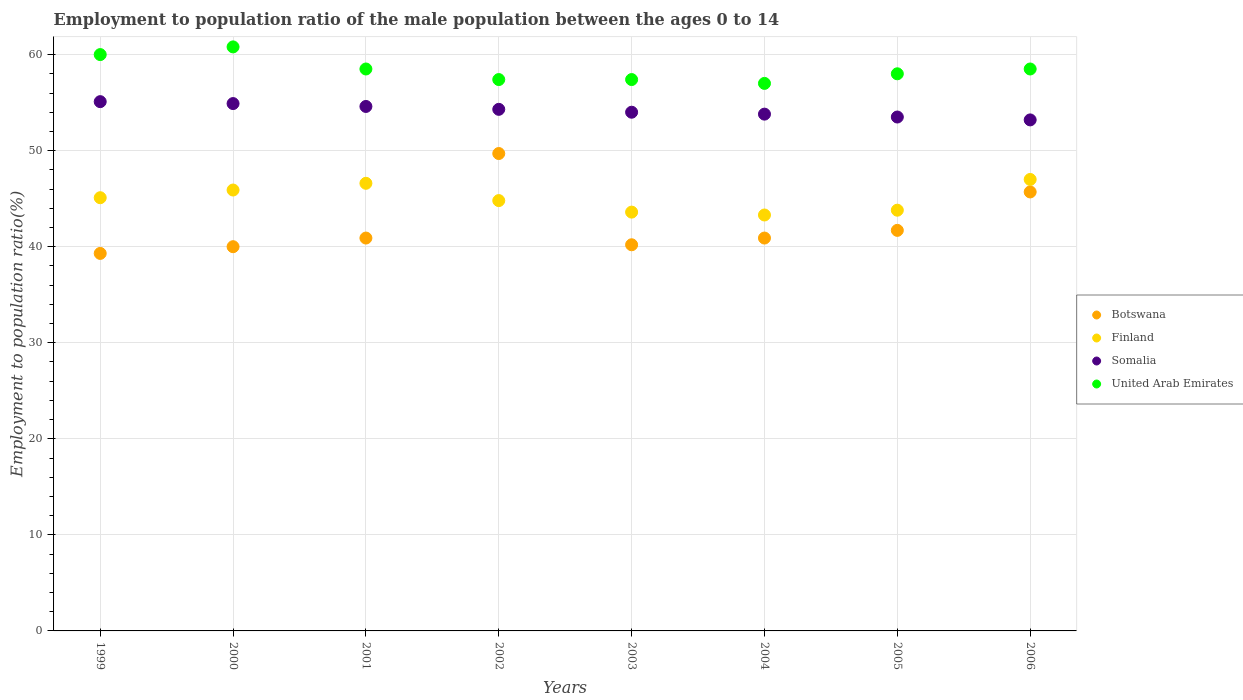How many different coloured dotlines are there?
Ensure brevity in your answer.  4. Across all years, what is the maximum employment to population ratio in United Arab Emirates?
Keep it short and to the point. 60.8. Across all years, what is the minimum employment to population ratio in Somalia?
Make the answer very short. 53.2. In which year was the employment to population ratio in Botswana maximum?
Provide a succinct answer. 2002. In which year was the employment to population ratio in United Arab Emirates minimum?
Provide a succinct answer. 2004. What is the total employment to population ratio in Finland in the graph?
Provide a succinct answer. 360.1. What is the difference between the employment to population ratio in Botswana in 2003 and that in 2004?
Your answer should be compact. -0.7. What is the difference between the employment to population ratio in Finland in 2006 and the employment to population ratio in Somalia in 2004?
Provide a short and direct response. -6.8. What is the average employment to population ratio in United Arab Emirates per year?
Keep it short and to the point. 58.45. In the year 1999, what is the difference between the employment to population ratio in Finland and employment to population ratio in United Arab Emirates?
Offer a terse response. -14.9. In how many years, is the employment to population ratio in Botswana greater than 10 %?
Give a very brief answer. 8. What is the ratio of the employment to population ratio in United Arab Emirates in 2004 to that in 2006?
Your answer should be compact. 0.97. Is the employment to population ratio in Finland in 1999 less than that in 2005?
Offer a terse response. No. What is the difference between the highest and the second highest employment to population ratio in Somalia?
Give a very brief answer. 0.2. What is the difference between the highest and the lowest employment to population ratio in United Arab Emirates?
Ensure brevity in your answer.  3.8. In how many years, is the employment to population ratio in United Arab Emirates greater than the average employment to population ratio in United Arab Emirates taken over all years?
Ensure brevity in your answer.  4. Does the employment to population ratio in Finland monotonically increase over the years?
Provide a succinct answer. No. Is the employment to population ratio in Somalia strictly greater than the employment to population ratio in Botswana over the years?
Offer a terse response. Yes. Is the employment to population ratio in Botswana strictly less than the employment to population ratio in Finland over the years?
Provide a short and direct response. No. How many dotlines are there?
Make the answer very short. 4. How many years are there in the graph?
Offer a very short reply. 8. Are the values on the major ticks of Y-axis written in scientific E-notation?
Provide a succinct answer. No. Does the graph contain any zero values?
Your answer should be very brief. No. Does the graph contain grids?
Your answer should be very brief. Yes. Where does the legend appear in the graph?
Provide a short and direct response. Center right. How many legend labels are there?
Give a very brief answer. 4. What is the title of the graph?
Offer a terse response. Employment to population ratio of the male population between the ages 0 to 14. Does "Indonesia" appear as one of the legend labels in the graph?
Offer a very short reply. No. What is the label or title of the X-axis?
Keep it short and to the point. Years. What is the Employment to population ratio(%) of Botswana in 1999?
Make the answer very short. 39.3. What is the Employment to population ratio(%) of Finland in 1999?
Your answer should be very brief. 45.1. What is the Employment to population ratio(%) in Somalia in 1999?
Your answer should be compact. 55.1. What is the Employment to population ratio(%) of Finland in 2000?
Make the answer very short. 45.9. What is the Employment to population ratio(%) of Somalia in 2000?
Provide a succinct answer. 54.9. What is the Employment to population ratio(%) in United Arab Emirates in 2000?
Your answer should be compact. 60.8. What is the Employment to population ratio(%) in Botswana in 2001?
Your answer should be very brief. 40.9. What is the Employment to population ratio(%) in Finland in 2001?
Provide a short and direct response. 46.6. What is the Employment to population ratio(%) in Somalia in 2001?
Offer a terse response. 54.6. What is the Employment to population ratio(%) in United Arab Emirates in 2001?
Ensure brevity in your answer.  58.5. What is the Employment to population ratio(%) in Botswana in 2002?
Offer a very short reply. 49.7. What is the Employment to population ratio(%) of Finland in 2002?
Your answer should be compact. 44.8. What is the Employment to population ratio(%) of Somalia in 2002?
Your response must be concise. 54.3. What is the Employment to population ratio(%) in United Arab Emirates in 2002?
Ensure brevity in your answer.  57.4. What is the Employment to population ratio(%) in Botswana in 2003?
Your answer should be compact. 40.2. What is the Employment to population ratio(%) in Finland in 2003?
Keep it short and to the point. 43.6. What is the Employment to population ratio(%) of Somalia in 2003?
Provide a short and direct response. 54. What is the Employment to population ratio(%) in United Arab Emirates in 2003?
Ensure brevity in your answer.  57.4. What is the Employment to population ratio(%) in Botswana in 2004?
Keep it short and to the point. 40.9. What is the Employment to population ratio(%) in Finland in 2004?
Offer a terse response. 43.3. What is the Employment to population ratio(%) of Somalia in 2004?
Your answer should be compact. 53.8. What is the Employment to population ratio(%) in Botswana in 2005?
Offer a very short reply. 41.7. What is the Employment to population ratio(%) of Finland in 2005?
Your response must be concise. 43.8. What is the Employment to population ratio(%) in Somalia in 2005?
Offer a very short reply. 53.5. What is the Employment to population ratio(%) of United Arab Emirates in 2005?
Ensure brevity in your answer.  58. What is the Employment to population ratio(%) in Botswana in 2006?
Keep it short and to the point. 45.7. What is the Employment to population ratio(%) in Somalia in 2006?
Offer a terse response. 53.2. What is the Employment to population ratio(%) in United Arab Emirates in 2006?
Give a very brief answer. 58.5. Across all years, what is the maximum Employment to population ratio(%) in Botswana?
Offer a very short reply. 49.7. Across all years, what is the maximum Employment to population ratio(%) in Finland?
Offer a terse response. 47. Across all years, what is the maximum Employment to population ratio(%) in Somalia?
Keep it short and to the point. 55.1. Across all years, what is the maximum Employment to population ratio(%) of United Arab Emirates?
Offer a terse response. 60.8. Across all years, what is the minimum Employment to population ratio(%) in Botswana?
Offer a terse response. 39.3. Across all years, what is the minimum Employment to population ratio(%) in Finland?
Your answer should be compact. 43.3. Across all years, what is the minimum Employment to population ratio(%) of Somalia?
Offer a terse response. 53.2. What is the total Employment to population ratio(%) of Botswana in the graph?
Offer a very short reply. 338.4. What is the total Employment to population ratio(%) in Finland in the graph?
Make the answer very short. 360.1. What is the total Employment to population ratio(%) in Somalia in the graph?
Provide a short and direct response. 433.4. What is the total Employment to population ratio(%) of United Arab Emirates in the graph?
Your answer should be compact. 467.6. What is the difference between the Employment to population ratio(%) in Finland in 1999 and that in 2000?
Your response must be concise. -0.8. What is the difference between the Employment to population ratio(%) in Somalia in 1999 and that in 2000?
Ensure brevity in your answer.  0.2. What is the difference between the Employment to population ratio(%) in United Arab Emirates in 1999 and that in 2001?
Keep it short and to the point. 1.5. What is the difference between the Employment to population ratio(%) in Botswana in 1999 and that in 2002?
Your answer should be very brief. -10.4. What is the difference between the Employment to population ratio(%) in Finland in 1999 and that in 2002?
Provide a short and direct response. 0.3. What is the difference between the Employment to population ratio(%) of Somalia in 1999 and that in 2002?
Your answer should be compact. 0.8. What is the difference between the Employment to population ratio(%) of Finland in 1999 and that in 2003?
Your answer should be compact. 1.5. What is the difference between the Employment to population ratio(%) in United Arab Emirates in 1999 and that in 2003?
Keep it short and to the point. 2.6. What is the difference between the Employment to population ratio(%) in Finland in 1999 and that in 2004?
Your answer should be very brief. 1.8. What is the difference between the Employment to population ratio(%) in Botswana in 1999 and that in 2005?
Your response must be concise. -2.4. What is the difference between the Employment to population ratio(%) in Finland in 1999 and that in 2005?
Keep it short and to the point. 1.3. What is the difference between the Employment to population ratio(%) of Finland in 1999 and that in 2006?
Give a very brief answer. -1.9. What is the difference between the Employment to population ratio(%) in Somalia in 1999 and that in 2006?
Make the answer very short. 1.9. What is the difference between the Employment to population ratio(%) of Botswana in 2000 and that in 2001?
Your answer should be compact. -0.9. What is the difference between the Employment to population ratio(%) of Somalia in 2000 and that in 2001?
Offer a very short reply. 0.3. What is the difference between the Employment to population ratio(%) in United Arab Emirates in 2000 and that in 2001?
Make the answer very short. 2.3. What is the difference between the Employment to population ratio(%) in Botswana in 2000 and that in 2002?
Make the answer very short. -9.7. What is the difference between the Employment to population ratio(%) in Botswana in 2000 and that in 2003?
Provide a succinct answer. -0.2. What is the difference between the Employment to population ratio(%) in United Arab Emirates in 2000 and that in 2003?
Keep it short and to the point. 3.4. What is the difference between the Employment to population ratio(%) of Finland in 2000 and that in 2004?
Offer a terse response. 2.6. What is the difference between the Employment to population ratio(%) of Somalia in 2000 and that in 2004?
Keep it short and to the point. 1.1. What is the difference between the Employment to population ratio(%) of United Arab Emirates in 2000 and that in 2004?
Ensure brevity in your answer.  3.8. What is the difference between the Employment to population ratio(%) of Botswana in 2000 and that in 2005?
Offer a terse response. -1.7. What is the difference between the Employment to population ratio(%) of Finland in 2000 and that in 2005?
Give a very brief answer. 2.1. What is the difference between the Employment to population ratio(%) in United Arab Emirates in 2000 and that in 2005?
Provide a succinct answer. 2.8. What is the difference between the Employment to population ratio(%) in Botswana in 2000 and that in 2006?
Give a very brief answer. -5.7. What is the difference between the Employment to population ratio(%) in United Arab Emirates in 2000 and that in 2006?
Ensure brevity in your answer.  2.3. What is the difference between the Employment to population ratio(%) of Botswana in 2001 and that in 2002?
Ensure brevity in your answer.  -8.8. What is the difference between the Employment to population ratio(%) in Finland in 2001 and that in 2002?
Your response must be concise. 1.8. What is the difference between the Employment to population ratio(%) in Somalia in 2001 and that in 2002?
Your answer should be compact. 0.3. What is the difference between the Employment to population ratio(%) of United Arab Emirates in 2001 and that in 2002?
Offer a terse response. 1.1. What is the difference between the Employment to population ratio(%) of Finland in 2001 and that in 2003?
Offer a very short reply. 3. What is the difference between the Employment to population ratio(%) of United Arab Emirates in 2001 and that in 2003?
Provide a succinct answer. 1.1. What is the difference between the Employment to population ratio(%) of Botswana in 2001 and that in 2004?
Keep it short and to the point. 0. What is the difference between the Employment to population ratio(%) of Finland in 2001 and that in 2004?
Offer a very short reply. 3.3. What is the difference between the Employment to population ratio(%) of Finland in 2001 and that in 2005?
Offer a terse response. 2.8. What is the difference between the Employment to population ratio(%) in United Arab Emirates in 2001 and that in 2005?
Provide a short and direct response. 0.5. What is the difference between the Employment to population ratio(%) of Finland in 2001 and that in 2006?
Your answer should be compact. -0.4. What is the difference between the Employment to population ratio(%) of Botswana in 2002 and that in 2003?
Your answer should be very brief. 9.5. What is the difference between the Employment to population ratio(%) of Finland in 2002 and that in 2003?
Make the answer very short. 1.2. What is the difference between the Employment to population ratio(%) of Finland in 2002 and that in 2004?
Your answer should be compact. 1.5. What is the difference between the Employment to population ratio(%) of Somalia in 2002 and that in 2004?
Offer a terse response. 0.5. What is the difference between the Employment to population ratio(%) of Botswana in 2002 and that in 2005?
Ensure brevity in your answer.  8. What is the difference between the Employment to population ratio(%) of Finland in 2002 and that in 2005?
Your response must be concise. 1. What is the difference between the Employment to population ratio(%) of Somalia in 2002 and that in 2005?
Give a very brief answer. 0.8. What is the difference between the Employment to population ratio(%) of Botswana in 2002 and that in 2006?
Keep it short and to the point. 4. What is the difference between the Employment to population ratio(%) of Finland in 2003 and that in 2004?
Provide a succinct answer. 0.3. What is the difference between the Employment to population ratio(%) of Botswana in 2003 and that in 2005?
Offer a terse response. -1.5. What is the difference between the Employment to population ratio(%) in Finland in 2003 and that in 2005?
Make the answer very short. -0.2. What is the difference between the Employment to population ratio(%) of Somalia in 2003 and that in 2006?
Keep it short and to the point. 0.8. What is the difference between the Employment to population ratio(%) of United Arab Emirates in 2003 and that in 2006?
Keep it short and to the point. -1.1. What is the difference between the Employment to population ratio(%) of Botswana in 2004 and that in 2005?
Ensure brevity in your answer.  -0.8. What is the difference between the Employment to population ratio(%) of United Arab Emirates in 2004 and that in 2005?
Provide a short and direct response. -1. What is the difference between the Employment to population ratio(%) in Botswana in 2004 and that in 2006?
Keep it short and to the point. -4.8. What is the difference between the Employment to population ratio(%) in Botswana in 2005 and that in 2006?
Give a very brief answer. -4. What is the difference between the Employment to population ratio(%) of Finland in 2005 and that in 2006?
Make the answer very short. -3.2. What is the difference between the Employment to population ratio(%) of Botswana in 1999 and the Employment to population ratio(%) of Finland in 2000?
Provide a short and direct response. -6.6. What is the difference between the Employment to population ratio(%) in Botswana in 1999 and the Employment to population ratio(%) in Somalia in 2000?
Your answer should be very brief. -15.6. What is the difference between the Employment to population ratio(%) of Botswana in 1999 and the Employment to population ratio(%) of United Arab Emirates in 2000?
Make the answer very short. -21.5. What is the difference between the Employment to population ratio(%) of Finland in 1999 and the Employment to population ratio(%) of Somalia in 2000?
Make the answer very short. -9.8. What is the difference between the Employment to population ratio(%) of Finland in 1999 and the Employment to population ratio(%) of United Arab Emirates in 2000?
Provide a short and direct response. -15.7. What is the difference between the Employment to population ratio(%) of Botswana in 1999 and the Employment to population ratio(%) of Finland in 2001?
Ensure brevity in your answer.  -7.3. What is the difference between the Employment to population ratio(%) in Botswana in 1999 and the Employment to population ratio(%) in Somalia in 2001?
Provide a succinct answer. -15.3. What is the difference between the Employment to population ratio(%) in Botswana in 1999 and the Employment to population ratio(%) in United Arab Emirates in 2001?
Your answer should be very brief. -19.2. What is the difference between the Employment to population ratio(%) of Botswana in 1999 and the Employment to population ratio(%) of Finland in 2002?
Your response must be concise. -5.5. What is the difference between the Employment to population ratio(%) in Botswana in 1999 and the Employment to population ratio(%) in Somalia in 2002?
Keep it short and to the point. -15. What is the difference between the Employment to population ratio(%) in Botswana in 1999 and the Employment to population ratio(%) in United Arab Emirates in 2002?
Offer a very short reply. -18.1. What is the difference between the Employment to population ratio(%) of Somalia in 1999 and the Employment to population ratio(%) of United Arab Emirates in 2002?
Provide a short and direct response. -2.3. What is the difference between the Employment to population ratio(%) of Botswana in 1999 and the Employment to population ratio(%) of Somalia in 2003?
Your answer should be compact. -14.7. What is the difference between the Employment to population ratio(%) of Botswana in 1999 and the Employment to population ratio(%) of United Arab Emirates in 2003?
Your answer should be very brief. -18.1. What is the difference between the Employment to population ratio(%) of Somalia in 1999 and the Employment to population ratio(%) of United Arab Emirates in 2003?
Keep it short and to the point. -2.3. What is the difference between the Employment to population ratio(%) in Botswana in 1999 and the Employment to population ratio(%) in Finland in 2004?
Provide a succinct answer. -4. What is the difference between the Employment to population ratio(%) in Botswana in 1999 and the Employment to population ratio(%) in United Arab Emirates in 2004?
Provide a short and direct response. -17.7. What is the difference between the Employment to population ratio(%) of Somalia in 1999 and the Employment to population ratio(%) of United Arab Emirates in 2004?
Ensure brevity in your answer.  -1.9. What is the difference between the Employment to population ratio(%) of Botswana in 1999 and the Employment to population ratio(%) of Somalia in 2005?
Give a very brief answer. -14.2. What is the difference between the Employment to population ratio(%) of Botswana in 1999 and the Employment to population ratio(%) of United Arab Emirates in 2005?
Keep it short and to the point. -18.7. What is the difference between the Employment to population ratio(%) of Finland in 1999 and the Employment to population ratio(%) of Somalia in 2005?
Your answer should be compact. -8.4. What is the difference between the Employment to population ratio(%) in Finland in 1999 and the Employment to population ratio(%) in United Arab Emirates in 2005?
Your response must be concise. -12.9. What is the difference between the Employment to population ratio(%) of Somalia in 1999 and the Employment to population ratio(%) of United Arab Emirates in 2005?
Give a very brief answer. -2.9. What is the difference between the Employment to population ratio(%) in Botswana in 1999 and the Employment to population ratio(%) in Finland in 2006?
Provide a short and direct response. -7.7. What is the difference between the Employment to population ratio(%) in Botswana in 1999 and the Employment to population ratio(%) in Somalia in 2006?
Provide a short and direct response. -13.9. What is the difference between the Employment to population ratio(%) in Botswana in 1999 and the Employment to population ratio(%) in United Arab Emirates in 2006?
Your answer should be compact. -19.2. What is the difference between the Employment to population ratio(%) of Finland in 1999 and the Employment to population ratio(%) of Somalia in 2006?
Ensure brevity in your answer.  -8.1. What is the difference between the Employment to population ratio(%) in Botswana in 2000 and the Employment to population ratio(%) in Somalia in 2001?
Your answer should be compact. -14.6. What is the difference between the Employment to population ratio(%) of Botswana in 2000 and the Employment to population ratio(%) of United Arab Emirates in 2001?
Your answer should be compact. -18.5. What is the difference between the Employment to population ratio(%) in Finland in 2000 and the Employment to population ratio(%) in Somalia in 2001?
Provide a short and direct response. -8.7. What is the difference between the Employment to population ratio(%) of Botswana in 2000 and the Employment to population ratio(%) of Finland in 2002?
Offer a very short reply. -4.8. What is the difference between the Employment to population ratio(%) of Botswana in 2000 and the Employment to population ratio(%) of Somalia in 2002?
Offer a very short reply. -14.3. What is the difference between the Employment to population ratio(%) in Botswana in 2000 and the Employment to population ratio(%) in United Arab Emirates in 2002?
Give a very brief answer. -17.4. What is the difference between the Employment to population ratio(%) of Finland in 2000 and the Employment to population ratio(%) of Somalia in 2002?
Give a very brief answer. -8.4. What is the difference between the Employment to population ratio(%) in Finland in 2000 and the Employment to population ratio(%) in United Arab Emirates in 2002?
Provide a short and direct response. -11.5. What is the difference between the Employment to population ratio(%) of Botswana in 2000 and the Employment to population ratio(%) of Somalia in 2003?
Provide a succinct answer. -14. What is the difference between the Employment to population ratio(%) of Botswana in 2000 and the Employment to population ratio(%) of United Arab Emirates in 2003?
Provide a succinct answer. -17.4. What is the difference between the Employment to population ratio(%) in Botswana in 2000 and the Employment to population ratio(%) in Finland in 2004?
Offer a very short reply. -3.3. What is the difference between the Employment to population ratio(%) in Botswana in 2000 and the Employment to population ratio(%) in Somalia in 2004?
Keep it short and to the point. -13.8. What is the difference between the Employment to population ratio(%) in Botswana in 2000 and the Employment to population ratio(%) in United Arab Emirates in 2005?
Your response must be concise. -18. What is the difference between the Employment to population ratio(%) of Finland in 2000 and the Employment to population ratio(%) of United Arab Emirates in 2005?
Your answer should be compact. -12.1. What is the difference between the Employment to population ratio(%) in Botswana in 2000 and the Employment to population ratio(%) in Somalia in 2006?
Your response must be concise. -13.2. What is the difference between the Employment to population ratio(%) in Botswana in 2000 and the Employment to population ratio(%) in United Arab Emirates in 2006?
Keep it short and to the point. -18.5. What is the difference between the Employment to population ratio(%) of Finland in 2000 and the Employment to population ratio(%) of Somalia in 2006?
Keep it short and to the point. -7.3. What is the difference between the Employment to population ratio(%) in Botswana in 2001 and the Employment to population ratio(%) in United Arab Emirates in 2002?
Your answer should be very brief. -16.5. What is the difference between the Employment to population ratio(%) in Finland in 2001 and the Employment to population ratio(%) in Somalia in 2002?
Make the answer very short. -7.7. What is the difference between the Employment to population ratio(%) of Somalia in 2001 and the Employment to population ratio(%) of United Arab Emirates in 2002?
Ensure brevity in your answer.  -2.8. What is the difference between the Employment to population ratio(%) in Botswana in 2001 and the Employment to population ratio(%) in Finland in 2003?
Offer a very short reply. -2.7. What is the difference between the Employment to population ratio(%) of Botswana in 2001 and the Employment to population ratio(%) of United Arab Emirates in 2003?
Your answer should be very brief. -16.5. What is the difference between the Employment to population ratio(%) in Finland in 2001 and the Employment to population ratio(%) in Somalia in 2003?
Ensure brevity in your answer.  -7.4. What is the difference between the Employment to population ratio(%) in Finland in 2001 and the Employment to population ratio(%) in United Arab Emirates in 2003?
Give a very brief answer. -10.8. What is the difference between the Employment to population ratio(%) of Somalia in 2001 and the Employment to population ratio(%) of United Arab Emirates in 2003?
Offer a very short reply. -2.8. What is the difference between the Employment to population ratio(%) in Botswana in 2001 and the Employment to population ratio(%) in Somalia in 2004?
Your answer should be very brief. -12.9. What is the difference between the Employment to population ratio(%) in Botswana in 2001 and the Employment to population ratio(%) in United Arab Emirates in 2004?
Provide a succinct answer. -16.1. What is the difference between the Employment to population ratio(%) in Finland in 2001 and the Employment to population ratio(%) in Somalia in 2004?
Provide a succinct answer. -7.2. What is the difference between the Employment to population ratio(%) in Somalia in 2001 and the Employment to population ratio(%) in United Arab Emirates in 2004?
Make the answer very short. -2.4. What is the difference between the Employment to population ratio(%) of Botswana in 2001 and the Employment to population ratio(%) of Finland in 2005?
Offer a terse response. -2.9. What is the difference between the Employment to population ratio(%) in Botswana in 2001 and the Employment to population ratio(%) in United Arab Emirates in 2005?
Make the answer very short. -17.1. What is the difference between the Employment to population ratio(%) in Finland in 2001 and the Employment to population ratio(%) in Somalia in 2005?
Your answer should be very brief. -6.9. What is the difference between the Employment to population ratio(%) of Finland in 2001 and the Employment to population ratio(%) of United Arab Emirates in 2005?
Your response must be concise. -11.4. What is the difference between the Employment to population ratio(%) of Somalia in 2001 and the Employment to population ratio(%) of United Arab Emirates in 2005?
Your response must be concise. -3.4. What is the difference between the Employment to population ratio(%) of Botswana in 2001 and the Employment to population ratio(%) of United Arab Emirates in 2006?
Keep it short and to the point. -17.6. What is the difference between the Employment to population ratio(%) in Finland in 2001 and the Employment to population ratio(%) in Somalia in 2006?
Provide a succinct answer. -6.6. What is the difference between the Employment to population ratio(%) in Finland in 2001 and the Employment to population ratio(%) in United Arab Emirates in 2006?
Provide a succinct answer. -11.9. What is the difference between the Employment to population ratio(%) in Somalia in 2001 and the Employment to population ratio(%) in United Arab Emirates in 2006?
Your response must be concise. -3.9. What is the difference between the Employment to population ratio(%) in Finland in 2002 and the Employment to population ratio(%) in Somalia in 2003?
Your answer should be compact. -9.2. What is the difference between the Employment to population ratio(%) in Finland in 2002 and the Employment to population ratio(%) in United Arab Emirates in 2003?
Your answer should be very brief. -12.6. What is the difference between the Employment to population ratio(%) of Botswana in 2002 and the Employment to population ratio(%) of Finland in 2004?
Provide a short and direct response. 6.4. What is the difference between the Employment to population ratio(%) of Botswana in 2002 and the Employment to population ratio(%) of United Arab Emirates in 2004?
Keep it short and to the point. -7.3. What is the difference between the Employment to population ratio(%) of Somalia in 2002 and the Employment to population ratio(%) of United Arab Emirates in 2004?
Offer a very short reply. -2.7. What is the difference between the Employment to population ratio(%) in Botswana in 2002 and the Employment to population ratio(%) in Somalia in 2005?
Give a very brief answer. -3.8. What is the difference between the Employment to population ratio(%) of Botswana in 2002 and the Employment to population ratio(%) of United Arab Emirates in 2005?
Ensure brevity in your answer.  -8.3. What is the difference between the Employment to population ratio(%) in Finland in 2002 and the Employment to population ratio(%) in United Arab Emirates in 2005?
Offer a terse response. -13.2. What is the difference between the Employment to population ratio(%) in Somalia in 2002 and the Employment to population ratio(%) in United Arab Emirates in 2005?
Offer a very short reply. -3.7. What is the difference between the Employment to population ratio(%) in Botswana in 2002 and the Employment to population ratio(%) in Finland in 2006?
Make the answer very short. 2.7. What is the difference between the Employment to population ratio(%) of Finland in 2002 and the Employment to population ratio(%) of Somalia in 2006?
Give a very brief answer. -8.4. What is the difference between the Employment to population ratio(%) of Finland in 2002 and the Employment to population ratio(%) of United Arab Emirates in 2006?
Provide a succinct answer. -13.7. What is the difference between the Employment to population ratio(%) of Botswana in 2003 and the Employment to population ratio(%) of Somalia in 2004?
Your answer should be compact. -13.6. What is the difference between the Employment to population ratio(%) in Botswana in 2003 and the Employment to population ratio(%) in United Arab Emirates in 2004?
Offer a very short reply. -16.8. What is the difference between the Employment to population ratio(%) of Botswana in 2003 and the Employment to population ratio(%) of Somalia in 2005?
Keep it short and to the point. -13.3. What is the difference between the Employment to population ratio(%) of Botswana in 2003 and the Employment to population ratio(%) of United Arab Emirates in 2005?
Your answer should be very brief. -17.8. What is the difference between the Employment to population ratio(%) in Finland in 2003 and the Employment to population ratio(%) in United Arab Emirates in 2005?
Your answer should be very brief. -14.4. What is the difference between the Employment to population ratio(%) in Botswana in 2003 and the Employment to population ratio(%) in Finland in 2006?
Provide a short and direct response. -6.8. What is the difference between the Employment to population ratio(%) in Botswana in 2003 and the Employment to population ratio(%) in Somalia in 2006?
Provide a short and direct response. -13. What is the difference between the Employment to population ratio(%) of Botswana in 2003 and the Employment to population ratio(%) of United Arab Emirates in 2006?
Give a very brief answer. -18.3. What is the difference between the Employment to population ratio(%) of Finland in 2003 and the Employment to population ratio(%) of Somalia in 2006?
Ensure brevity in your answer.  -9.6. What is the difference between the Employment to population ratio(%) of Finland in 2003 and the Employment to population ratio(%) of United Arab Emirates in 2006?
Provide a succinct answer. -14.9. What is the difference between the Employment to population ratio(%) of Botswana in 2004 and the Employment to population ratio(%) of Finland in 2005?
Your answer should be very brief. -2.9. What is the difference between the Employment to population ratio(%) of Botswana in 2004 and the Employment to population ratio(%) of United Arab Emirates in 2005?
Your response must be concise. -17.1. What is the difference between the Employment to population ratio(%) in Finland in 2004 and the Employment to population ratio(%) in United Arab Emirates in 2005?
Provide a succinct answer. -14.7. What is the difference between the Employment to population ratio(%) in Botswana in 2004 and the Employment to population ratio(%) in United Arab Emirates in 2006?
Ensure brevity in your answer.  -17.6. What is the difference between the Employment to population ratio(%) in Finland in 2004 and the Employment to population ratio(%) in United Arab Emirates in 2006?
Your answer should be compact. -15.2. What is the difference between the Employment to population ratio(%) in Somalia in 2004 and the Employment to population ratio(%) in United Arab Emirates in 2006?
Your answer should be very brief. -4.7. What is the difference between the Employment to population ratio(%) in Botswana in 2005 and the Employment to population ratio(%) in Finland in 2006?
Your answer should be very brief. -5.3. What is the difference between the Employment to population ratio(%) in Botswana in 2005 and the Employment to population ratio(%) in United Arab Emirates in 2006?
Offer a terse response. -16.8. What is the difference between the Employment to population ratio(%) in Finland in 2005 and the Employment to population ratio(%) in Somalia in 2006?
Your answer should be compact. -9.4. What is the difference between the Employment to population ratio(%) in Finland in 2005 and the Employment to population ratio(%) in United Arab Emirates in 2006?
Keep it short and to the point. -14.7. What is the average Employment to population ratio(%) of Botswana per year?
Your answer should be very brief. 42.3. What is the average Employment to population ratio(%) in Finland per year?
Provide a succinct answer. 45.01. What is the average Employment to population ratio(%) in Somalia per year?
Offer a terse response. 54.17. What is the average Employment to population ratio(%) of United Arab Emirates per year?
Your answer should be compact. 58.45. In the year 1999, what is the difference between the Employment to population ratio(%) of Botswana and Employment to population ratio(%) of Finland?
Ensure brevity in your answer.  -5.8. In the year 1999, what is the difference between the Employment to population ratio(%) of Botswana and Employment to population ratio(%) of Somalia?
Provide a succinct answer. -15.8. In the year 1999, what is the difference between the Employment to population ratio(%) of Botswana and Employment to population ratio(%) of United Arab Emirates?
Give a very brief answer. -20.7. In the year 1999, what is the difference between the Employment to population ratio(%) in Finland and Employment to population ratio(%) in United Arab Emirates?
Give a very brief answer. -14.9. In the year 1999, what is the difference between the Employment to population ratio(%) in Somalia and Employment to population ratio(%) in United Arab Emirates?
Keep it short and to the point. -4.9. In the year 2000, what is the difference between the Employment to population ratio(%) in Botswana and Employment to population ratio(%) in Somalia?
Keep it short and to the point. -14.9. In the year 2000, what is the difference between the Employment to population ratio(%) of Botswana and Employment to population ratio(%) of United Arab Emirates?
Ensure brevity in your answer.  -20.8. In the year 2000, what is the difference between the Employment to population ratio(%) in Finland and Employment to population ratio(%) in United Arab Emirates?
Your answer should be very brief. -14.9. In the year 2000, what is the difference between the Employment to population ratio(%) in Somalia and Employment to population ratio(%) in United Arab Emirates?
Offer a terse response. -5.9. In the year 2001, what is the difference between the Employment to population ratio(%) of Botswana and Employment to population ratio(%) of Somalia?
Your answer should be very brief. -13.7. In the year 2001, what is the difference between the Employment to population ratio(%) of Botswana and Employment to population ratio(%) of United Arab Emirates?
Your response must be concise. -17.6. In the year 2001, what is the difference between the Employment to population ratio(%) in Finland and Employment to population ratio(%) in United Arab Emirates?
Offer a terse response. -11.9. In the year 2002, what is the difference between the Employment to population ratio(%) in Botswana and Employment to population ratio(%) in Finland?
Make the answer very short. 4.9. In the year 2002, what is the difference between the Employment to population ratio(%) in Botswana and Employment to population ratio(%) in Somalia?
Give a very brief answer. -4.6. In the year 2002, what is the difference between the Employment to population ratio(%) in Finland and Employment to population ratio(%) in Somalia?
Offer a terse response. -9.5. In the year 2003, what is the difference between the Employment to population ratio(%) of Botswana and Employment to population ratio(%) of United Arab Emirates?
Your answer should be compact. -17.2. In the year 2003, what is the difference between the Employment to population ratio(%) in Somalia and Employment to population ratio(%) in United Arab Emirates?
Your response must be concise. -3.4. In the year 2004, what is the difference between the Employment to population ratio(%) of Botswana and Employment to population ratio(%) of Finland?
Your response must be concise. -2.4. In the year 2004, what is the difference between the Employment to population ratio(%) in Botswana and Employment to population ratio(%) in United Arab Emirates?
Provide a succinct answer. -16.1. In the year 2004, what is the difference between the Employment to population ratio(%) of Finland and Employment to population ratio(%) of Somalia?
Your answer should be very brief. -10.5. In the year 2004, what is the difference between the Employment to population ratio(%) in Finland and Employment to population ratio(%) in United Arab Emirates?
Your answer should be very brief. -13.7. In the year 2005, what is the difference between the Employment to population ratio(%) of Botswana and Employment to population ratio(%) of United Arab Emirates?
Ensure brevity in your answer.  -16.3. In the year 2005, what is the difference between the Employment to population ratio(%) in Finland and Employment to population ratio(%) in Somalia?
Offer a terse response. -9.7. In the year 2005, what is the difference between the Employment to population ratio(%) of Somalia and Employment to population ratio(%) of United Arab Emirates?
Provide a short and direct response. -4.5. In the year 2006, what is the difference between the Employment to population ratio(%) in Botswana and Employment to population ratio(%) in Somalia?
Provide a succinct answer. -7.5. In the year 2006, what is the difference between the Employment to population ratio(%) of Finland and Employment to population ratio(%) of Somalia?
Offer a very short reply. -6.2. What is the ratio of the Employment to population ratio(%) of Botswana in 1999 to that in 2000?
Give a very brief answer. 0.98. What is the ratio of the Employment to population ratio(%) of Finland in 1999 to that in 2000?
Offer a very short reply. 0.98. What is the ratio of the Employment to population ratio(%) in Somalia in 1999 to that in 2000?
Your answer should be very brief. 1. What is the ratio of the Employment to population ratio(%) in United Arab Emirates in 1999 to that in 2000?
Offer a very short reply. 0.99. What is the ratio of the Employment to population ratio(%) of Botswana in 1999 to that in 2001?
Offer a very short reply. 0.96. What is the ratio of the Employment to population ratio(%) of Finland in 1999 to that in 2001?
Give a very brief answer. 0.97. What is the ratio of the Employment to population ratio(%) of Somalia in 1999 to that in 2001?
Offer a terse response. 1.01. What is the ratio of the Employment to population ratio(%) of United Arab Emirates in 1999 to that in 2001?
Offer a terse response. 1.03. What is the ratio of the Employment to population ratio(%) in Botswana in 1999 to that in 2002?
Provide a short and direct response. 0.79. What is the ratio of the Employment to population ratio(%) in Somalia in 1999 to that in 2002?
Your response must be concise. 1.01. What is the ratio of the Employment to population ratio(%) of United Arab Emirates in 1999 to that in 2002?
Your answer should be compact. 1.05. What is the ratio of the Employment to population ratio(%) of Botswana in 1999 to that in 2003?
Ensure brevity in your answer.  0.98. What is the ratio of the Employment to population ratio(%) of Finland in 1999 to that in 2003?
Your answer should be very brief. 1.03. What is the ratio of the Employment to population ratio(%) in Somalia in 1999 to that in 2003?
Your answer should be very brief. 1.02. What is the ratio of the Employment to population ratio(%) in United Arab Emirates in 1999 to that in 2003?
Provide a succinct answer. 1.05. What is the ratio of the Employment to population ratio(%) in Botswana in 1999 to that in 2004?
Your response must be concise. 0.96. What is the ratio of the Employment to population ratio(%) of Finland in 1999 to that in 2004?
Your answer should be very brief. 1.04. What is the ratio of the Employment to population ratio(%) in Somalia in 1999 to that in 2004?
Offer a terse response. 1.02. What is the ratio of the Employment to population ratio(%) of United Arab Emirates in 1999 to that in 2004?
Offer a terse response. 1.05. What is the ratio of the Employment to population ratio(%) of Botswana in 1999 to that in 2005?
Offer a very short reply. 0.94. What is the ratio of the Employment to population ratio(%) in Finland in 1999 to that in 2005?
Provide a short and direct response. 1.03. What is the ratio of the Employment to population ratio(%) in Somalia in 1999 to that in 2005?
Your response must be concise. 1.03. What is the ratio of the Employment to population ratio(%) of United Arab Emirates in 1999 to that in 2005?
Your answer should be very brief. 1.03. What is the ratio of the Employment to population ratio(%) in Botswana in 1999 to that in 2006?
Your response must be concise. 0.86. What is the ratio of the Employment to population ratio(%) of Finland in 1999 to that in 2006?
Make the answer very short. 0.96. What is the ratio of the Employment to population ratio(%) in Somalia in 1999 to that in 2006?
Offer a very short reply. 1.04. What is the ratio of the Employment to population ratio(%) of United Arab Emirates in 1999 to that in 2006?
Offer a terse response. 1.03. What is the ratio of the Employment to population ratio(%) of Somalia in 2000 to that in 2001?
Offer a terse response. 1.01. What is the ratio of the Employment to population ratio(%) of United Arab Emirates in 2000 to that in 2001?
Provide a succinct answer. 1.04. What is the ratio of the Employment to population ratio(%) in Botswana in 2000 to that in 2002?
Your response must be concise. 0.8. What is the ratio of the Employment to population ratio(%) of Finland in 2000 to that in 2002?
Your answer should be compact. 1.02. What is the ratio of the Employment to population ratio(%) of United Arab Emirates in 2000 to that in 2002?
Make the answer very short. 1.06. What is the ratio of the Employment to population ratio(%) in Botswana in 2000 to that in 2003?
Offer a very short reply. 0.99. What is the ratio of the Employment to population ratio(%) in Finland in 2000 to that in 2003?
Offer a terse response. 1.05. What is the ratio of the Employment to population ratio(%) of Somalia in 2000 to that in 2003?
Your answer should be compact. 1.02. What is the ratio of the Employment to population ratio(%) in United Arab Emirates in 2000 to that in 2003?
Ensure brevity in your answer.  1.06. What is the ratio of the Employment to population ratio(%) in Botswana in 2000 to that in 2004?
Your answer should be compact. 0.98. What is the ratio of the Employment to population ratio(%) of Finland in 2000 to that in 2004?
Give a very brief answer. 1.06. What is the ratio of the Employment to population ratio(%) in Somalia in 2000 to that in 2004?
Keep it short and to the point. 1.02. What is the ratio of the Employment to population ratio(%) in United Arab Emirates in 2000 to that in 2004?
Offer a terse response. 1.07. What is the ratio of the Employment to population ratio(%) in Botswana in 2000 to that in 2005?
Keep it short and to the point. 0.96. What is the ratio of the Employment to population ratio(%) of Finland in 2000 to that in 2005?
Your response must be concise. 1.05. What is the ratio of the Employment to population ratio(%) of Somalia in 2000 to that in 2005?
Provide a succinct answer. 1.03. What is the ratio of the Employment to population ratio(%) of United Arab Emirates in 2000 to that in 2005?
Your answer should be very brief. 1.05. What is the ratio of the Employment to population ratio(%) of Botswana in 2000 to that in 2006?
Make the answer very short. 0.88. What is the ratio of the Employment to population ratio(%) in Finland in 2000 to that in 2006?
Your answer should be very brief. 0.98. What is the ratio of the Employment to population ratio(%) of Somalia in 2000 to that in 2006?
Your answer should be compact. 1.03. What is the ratio of the Employment to population ratio(%) in United Arab Emirates in 2000 to that in 2006?
Make the answer very short. 1.04. What is the ratio of the Employment to population ratio(%) in Botswana in 2001 to that in 2002?
Your answer should be very brief. 0.82. What is the ratio of the Employment to population ratio(%) in Finland in 2001 to that in 2002?
Provide a short and direct response. 1.04. What is the ratio of the Employment to population ratio(%) of United Arab Emirates in 2001 to that in 2002?
Make the answer very short. 1.02. What is the ratio of the Employment to population ratio(%) in Botswana in 2001 to that in 2003?
Offer a very short reply. 1.02. What is the ratio of the Employment to population ratio(%) of Finland in 2001 to that in 2003?
Make the answer very short. 1.07. What is the ratio of the Employment to population ratio(%) in Somalia in 2001 to that in 2003?
Give a very brief answer. 1.01. What is the ratio of the Employment to population ratio(%) of United Arab Emirates in 2001 to that in 2003?
Offer a terse response. 1.02. What is the ratio of the Employment to population ratio(%) of Botswana in 2001 to that in 2004?
Provide a succinct answer. 1. What is the ratio of the Employment to population ratio(%) of Finland in 2001 to that in 2004?
Offer a very short reply. 1.08. What is the ratio of the Employment to population ratio(%) of Somalia in 2001 to that in 2004?
Provide a succinct answer. 1.01. What is the ratio of the Employment to population ratio(%) of United Arab Emirates in 2001 to that in 2004?
Your answer should be very brief. 1.03. What is the ratio of the Employment to population ratio(%) of Botswana in 2001 to that in 2005?
Keep it short and to the point. 0.98. What is the ratio of the Employment to population ratio(%) in Finland in 2001 to that in 2005?
Ensure brevity in your answer.  1.06. What is the ratio of the Employment to population ratio(%) in Somalia in 2001 to that in 2005?
Your response must be concise. 1.02. What is the ratio of the Employment to population ratio(%) in United Arab Emirates in 2001 to that in 2005?
Make the answer very short. 1.01. What is the ratio of the Employment to population ratio(%) in Botswana in 2001 to that in 2006?
Ensure brevity in your answer.  0.9. What is the ratio of the Employment to population ratio(%) of Finland in 2001 to that in 2006?
Ensure brevity in your answer.  0.99. What is the ratio of the Employment to population ratio(%) of Somalia in 2001 to that in 2006?
Offer a terse response. 1.03. What is the ratio of the Employment to population ratio(%) in United Arab Emirates in 2001 to that in 2006?
Your answer should be very brief. 1. What is the ratio of the Employment to population ratio(%) of Botswana in 2002 to that in 2003?
Make the answer very short. 1.24. What is the ratio of the Employment to population ratio(%) of Finland in 2002 to that in 2003?
Your response must be concise. 1.03. What is the ratio of the Employment to population ratio(%) of Somalia in 2002 to that in 2003?
Offer a very short reply. 1.01. What is the ratio of the Employment to population ratio(%) of United Arab Emirates in 2002 to that in 2003?
Your answer should be compact. 1. What is the ratio of the Employment to population ratio(%) of Botswana in 2002 to that in 2004?
Provide a short and direct response. 1.22. What is the ratio of the Employment to population ratio(%) in Finland in 2002 to that in 2004?
Ensure brevity in your answer.  1.03. What is the ratio of the Employment to population ratio(%) of Somalia in 2002 to that in 2004?
Keep it short and to the point. 1.01. What is the ratio of the Employment to population ratio(%) of Botswana in 2002 to that in 2005?
Your response must be concise. 1.19. What is the ratio of the Employment to population ratio(%) in Finland in 2002 to that in 2005?
Offer a very short reply. 1.02. What is the ratio of the Employment to population ratio(%) of Somalia in 2002 to that in 2005?
Keep it short and to the point. 1.01. What is the ratio of the Employment to population ratio(%) of United Arab Emirates in 2002 to that in 2005?
Your response must be concise. 0.99. What is the ratio of the Employment to population ratio(%) in Botswana in 2002 to that in 2006?
Provide a succinct answer. 1.09. What is the ratio of the Employment to population ratio(%) in Finland in 2002 to that in 2006?
Offer a very short reply. 0.95. What is the ratio of the Employment to population ratio(%) of Somalia in 2002 to that in 2006?
Keep it short and to the point. 1.02. What is the ratio of the Employment to population ratio(%) in United Arab Emirates in 2002 to that in 2006?
Offer a very short reply. 0.98. What is the ratio of the Employment to population ratio(%) of Botswana in 2003 to that in 2004?
Give a very brief answer. 0.98. What is the ratio of the Employment to population ratio(%) of Finland in 2003 to that in 2004?
Your answer should be very brief. 1.01. What is the ratio of the Employment to population ratio(%) of United Arab Emirates in 2003 to that in 2004?
Give a very brief answer. 1.01. What is the ratio of the Employment to population ratio(%) of Botswana in 2003 to that in 2005?
Offer a very short reply. 0.96. What is the ratio of the Employment to population ratio(%) in Finland in 2003 to that in 2005?
Your response must be concise. 1. What is the ratio of the Employment to population ratio(%) in Somalia in 2003 to that in 2005?
Offer a very short reply. 1.01. What is the ratio of the Employment to population ratio(%) in United Arab Emirates in 2003 to that in 2005?
Offer a very short reply. 0.99. What is the ratio of the Employment to population ratio(%) of Botswana in 2003 to that in 2006?
Your response must be concise. 0.88. What is the ratio of the Employment to population ratio(%) of Finland in 2003 to that in 2006?
Ensure brevity in your answer.  0.93. What is the ratio of the Employment to population ratio(%) in Somalia in 2003 to that in 2006?
Provide a short and direct response. 1.01. What is the ratio of the Employment to population ratio(%) of United Arab Emirates in 2003 to that in 2006?
Give a very brief answer. 0.98. What is the ratio of the Employment to population ratio(%) of Botswana in 2004 to that in 2005?
Offer a terse response. 0.98. What is the ratio of the Employment to population ratio(%) of Somalia in 2004 to that in 2005?
Offer a very short reply. 1.01. What is the ratio of the Employment to population ratio(%) of United Arab Emirates in 2004 to that in 2005?
Your response must be concise. 0.98. What is the ratio of the Employment to population ratio(%) in Botswana in 2004 to that in 2006?
Offer a terse response. 0.9. What is the ratio of the Employment to population ratio(%) in Finland in 2004 to that in 2006?
Give a very brief answer. 0.92. What is the ratio of the Employment to population ratio(%) of Somalia in 2004 to that in 2006?
Offer a very short reply. 1.01. What is the ratio of the Employment to population ratio(%) of United Arab Emirates in 2004 to that in 2006?
Make the answer very short. 0.97. What is the ratio of the Employment to population ratio(%) of Botswana in 2005 to that in 2006?
Give a very brief answer. 0.91. What is the ratio of the Employment to population ratio(%) in Finland in 2005 to that in 2006?
Offer a very short reply. 0.93. What is the ratio of the Employment to population ratio(%) of Somalia in 2005 to that in 2006?
Your answer should be very brief. 1.01. What is the ratio of the Employment to population ratio(%) in United Arab Emirates in 2005 to that in 2006?
Offer a very short reply. 0.99. What is the difference between the highest and the second highest Employment to population ratio(%) in Somalia?
Your answer should be compact. 0.2. What is the difference between the highest and the lowest Employment to population ratio(%) in Botswana?
Provide a short and direct response. 10.4. What is the difference between the highest and the lowest Employment to population ratio(%) of United Arab Emirates?
Provide a succinct answer. 3.8. 